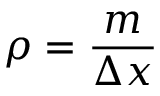<formula> <loc_0><loc_0><loc_500><loc_500>\rho = { \frac { m } { \Delta x } }</formula> 